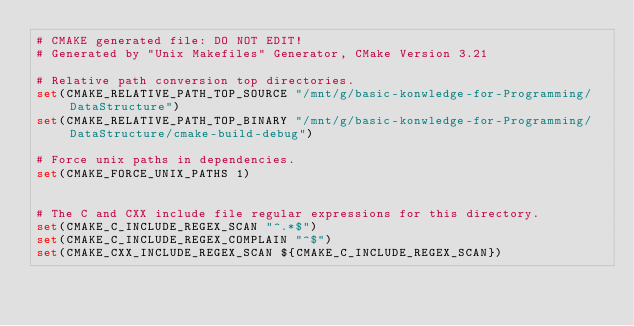Convert code to text. <code><loc_0><loc_0><loc_500><loc_500><_CMake_># CMAKE generated file: DO NOT EDIT!
# Generated by "Unix Makefiles" Generator, CMake Version 3.21

# Relative path conversion top directories.
set(CMAKE_RELATIVE_PATH_TOP_SOURCE "/mnt/g/basic-konwledge-for-Programming/DataStructure")
set(CMAKE_RELATIVE_PATH_TOP_BINARY "/mnt/g/basic-konwledge-for-Programming/DataStructure/cmake-build-debug")

# Force unix paths in dependencies.
set(CMAKE_FORCE_UNIX_PATHS 1)


# The C and CXX include file regular expressions for this directory.
set(CMAKE_C_INCLUDE_REGEX_SCAN "^.*$")
set(CMAKE_C_INCLUDE_REGEX_COMPLAIN "^$")
set(CMAKE_CXX_INCLUDE_REGEX_SCAN ${CMAKE_C_INCLUDE_REGEX_SCAN})</code> 